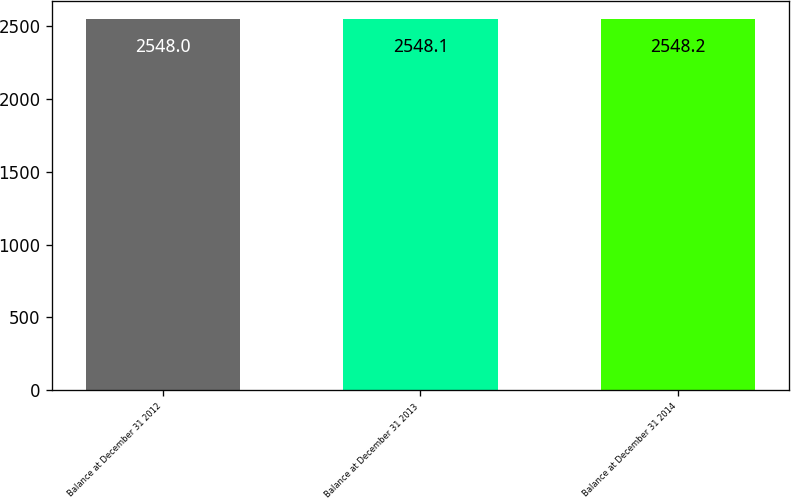Convert chart to OTSL. <chart><loc_0><loc_0><loc_500><loc_500><bar_chart><fcel>Balance at December 31 2012<fcel>Balance at December 31 2013<fcel>Balance at December 31 2014<nl><fcel>2548<fcel>2548.1<fcel>2548.2<nl></chart> 